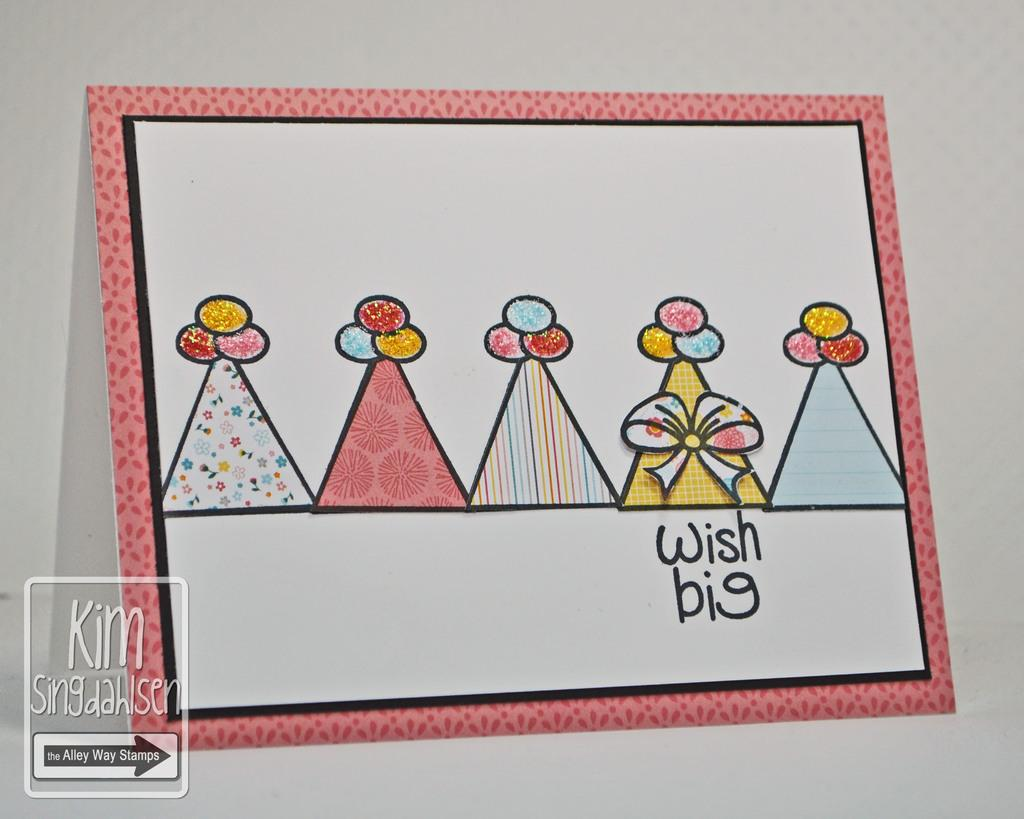<image>
Render a clear and concise summary of the photo. a greeting card with several gift looking items and stating about a wish big 